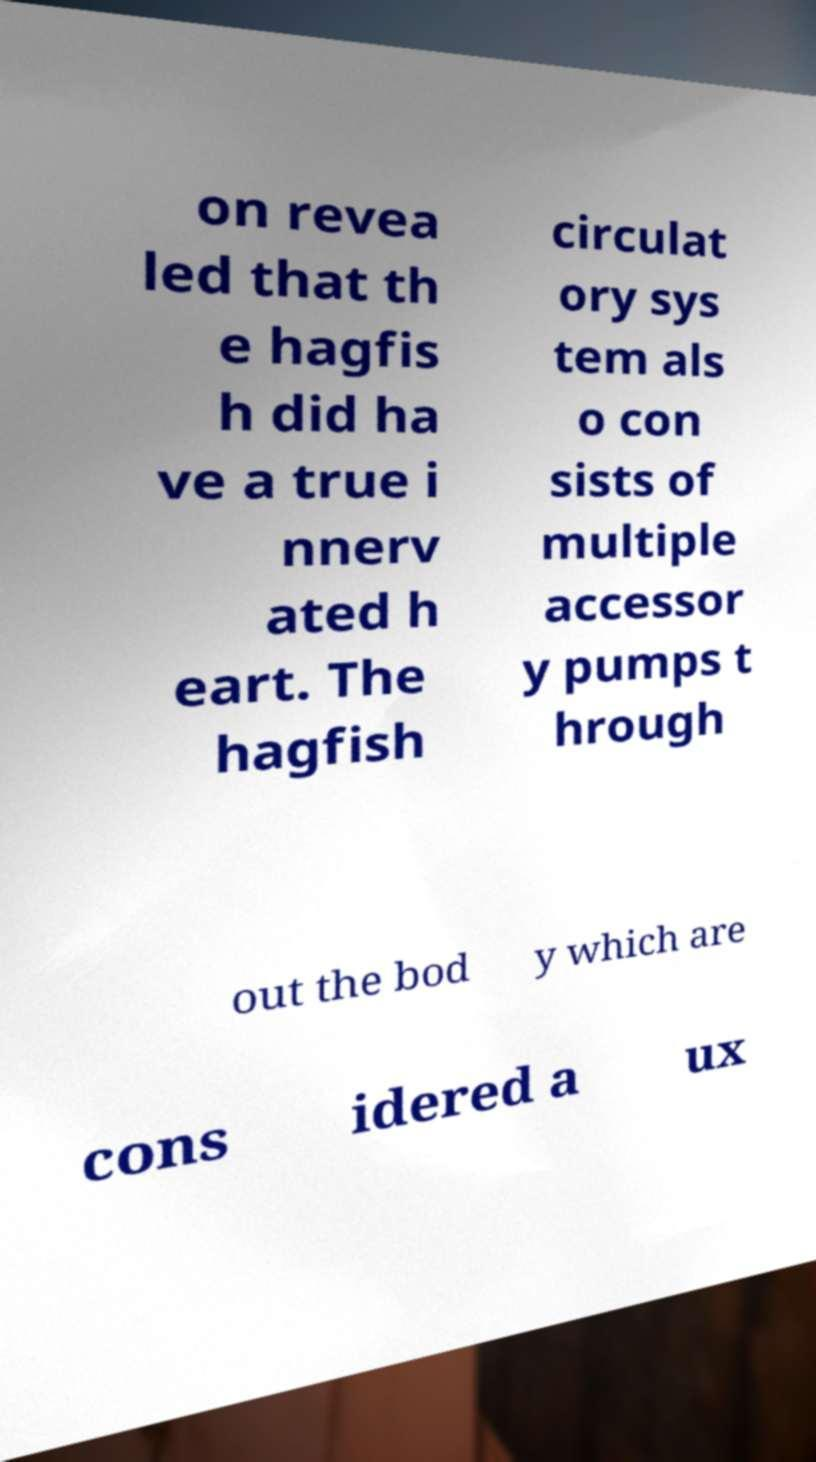I need the written content from this picture converted into text. Can you do that? on revea led that th e hagfis h did ha ve a true i nnerv ated h eart. The hagfish circulat ory sys tem als o con sists of multiple accessor y pumps t hrough out the bod y which are cons idered a ux 